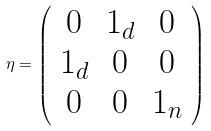<formula> <loc_0><loc_0><loc_500><loc_500>\eta = \left ( \begin{array} { c c c } { 0 } & { { { 1 } _ { d } } } & { 0 } \\ { { { 1 } _ { d } } } & { 0 } & { 0 } \\ { 0 } & { 0 } & { { { 1 } _ { n } } } \end{array} \right )</formula> 